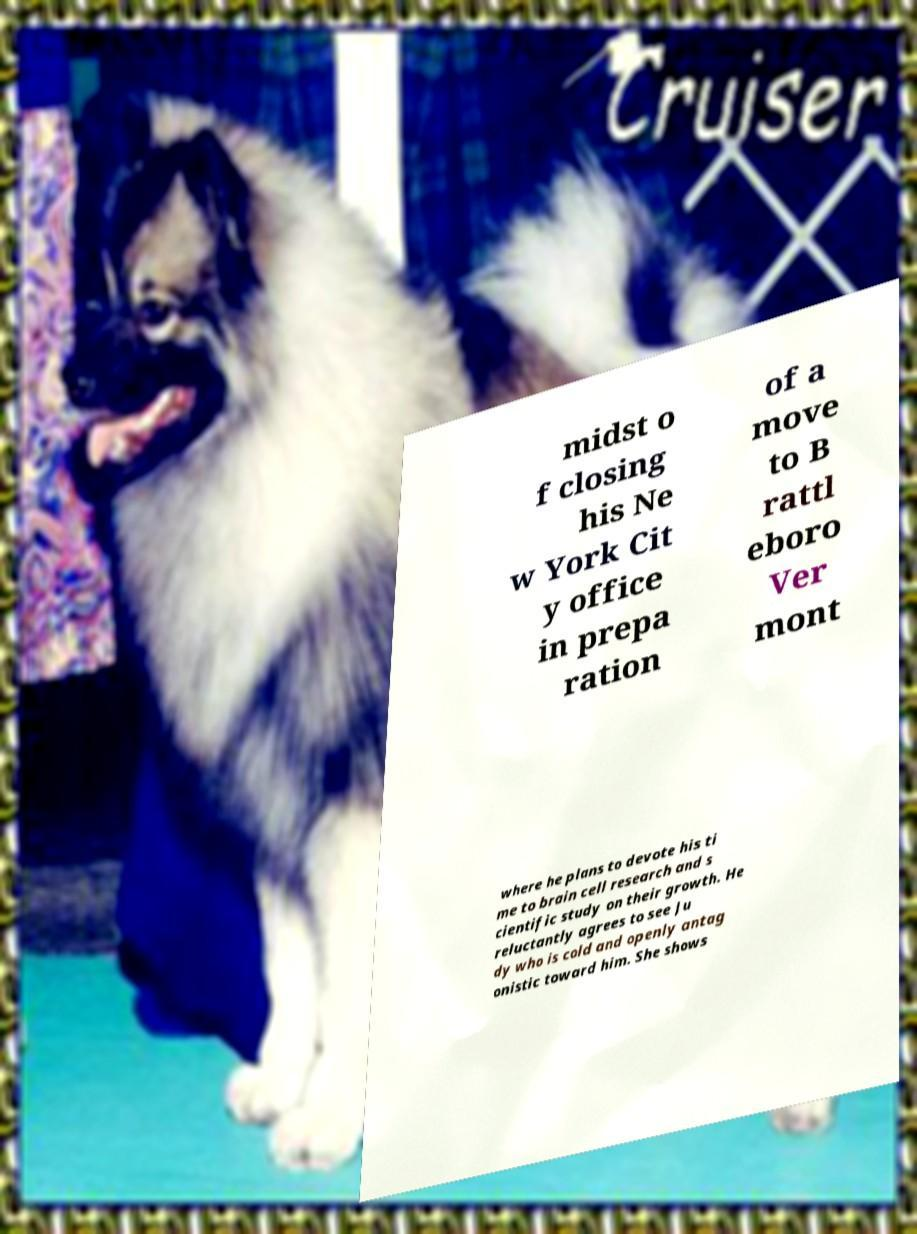Can you read and provide the text displayed in the image?This photo seems to have some interesting text. Can you extract and type it out for me? midst o f closing his Ne w York Cit y office in prepa ration of a move to B rattl eboro Ver mont where he plans to devote his ti me to brain cell research and s cientific study on their growth. He reluctantly agrees to see Ju dy who is cold and openly antag onistic toward him. She shows 